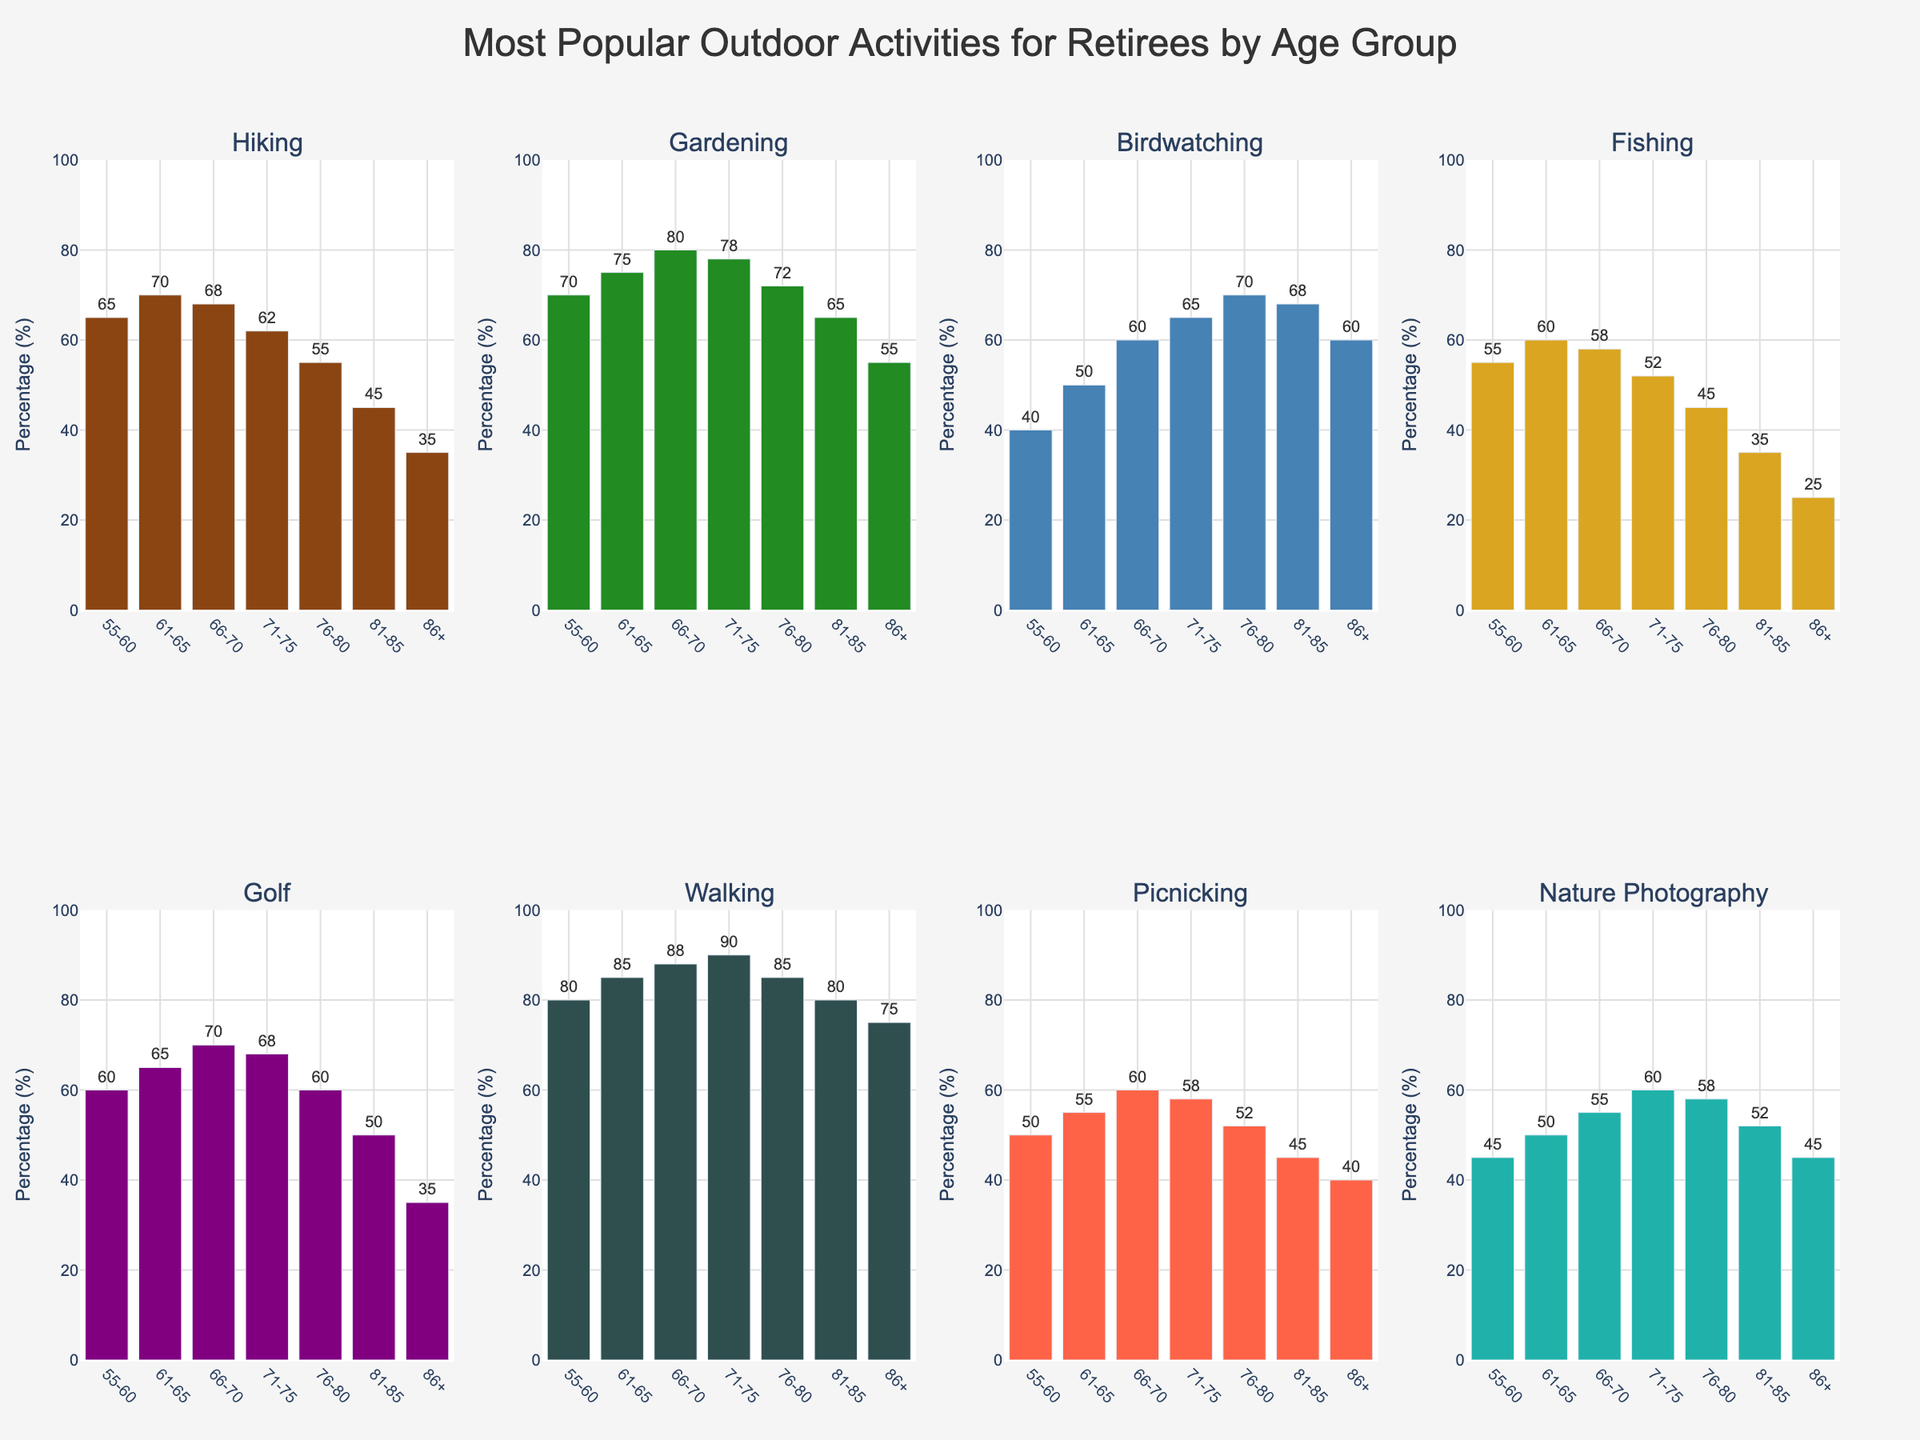Which age group has the highest percentage for walking? To find the highest percentage for walking, we need to compare the values for each age group in the walking category. These values are: 55-60 (80), 61-65 (85), 66-70 (88), 71-75 (90), 76-80 (85), 81-85 (80), 86+ (75). The highest value is 90 in the 71-75 age group.
Answer: 71-75 What is the average percentage of birdwatching across all age groups? To calculate the average percentage of birdwatching, sum the values for all age groups and divide by the number of age groups. The values are: 40, 50, 60, 65, 70, 68, 60. Sum = 413. Number of age groups = 7. Average = 413/7 ≈ 59
Answer: 59 Which activity has the least participation in the 86+ age group? For the 86+ age group, compare the percentage values for all activities: Hiking (35), Gardening (55), Birdwatching (60), Fishing (25), Golf (35), Walking (75), Picnicking (40), Nature Photography (45). The smallest value is Fishing at 25.
Answer: Fishing Is picnicking more popular than nature photography in the 66-70 age group? Compare the values for picnicking and nature photography in the 66-70 age group: Picnicking (60), Nature Photography (55). Picnicking value is greater than nature photography.
Answer: Yes Which age group shows the most significant decline in participation for golfing when compared to the immediately younger age group? Compare the percentage decreases between consecutive age groups: 55-60 to 61-65: 55 to 60 (+5), 61-65 to 66-70: 60 to 65 (+5), 66-70 to 71-75: 65 to 68 (+3), 71-75 to 76-80: 68 to 60 (-8), 76-80 to 81-85: 60 to 50 (-10), 81-85 to 86+: 50 to 35 (-15). The most significant decline is from 81-85 to 86+ with a decrease of 15.
Answer: 81-85 to 86+ Which activity in the 61-65 age group has the closest percentage to the 55-60 age group for fishing? The percentage for fishing in the 55-60 age group is 55. In the 61-65 age group, compare values of all activities: Hiking (70), Gardening (75), Birdwatching (50), Fishing (60), Golf (65), Walking (85), Picnicking (55), Nature Photography (50). Picnicking has the same percentage of 55.
Answer: Picnicking What is the range of percentages for gardening across the age groups? The highest percentage for gardening is 80 (66-70 age group), and the lowest is 55 (86+ age group). Range = 80 - 55 = 25.
Answer: 25 In which age group is birdwatching more popular than hiking? Compare the values of birdwatching and hiking for each age group. Birdwatching is more popular than hiking in the following age groups: 66-70 (60 vs 68), 71-75 (65 vs 62), 76-80 (70 vs 55), 81-85 (68 vs 45), 86+ (60 vs 35). So, birdwatching is more popular in these age groups: 66-70, 71-75, 76-80, 81-85, and 86+.
Answer: 66-70, 71-75, 76-80, 81-85, 86+ What is the difference in the percentage of hiking between the 55-60 and 86+ age groups? The percentage of hiking for the 55-60 age group is 65, and for the 86+ age group is 35. Difference = 65 - 35 = 30.
Answer: 30 